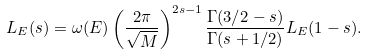<formula> <loc_0><loc_0><loc_500><loc_500>L _ { E } ( s ) = \omega ( E ) \left ( \frac { 2 \pi } { \sqrt { M } } \right ) ^ { 2 s - 1 } \frac { \Gamma ( 3 / 2 - s ) } { \Gamma ( s + 1 / 2 ) } L _ { E } ( 1 - s ) .</formula> 